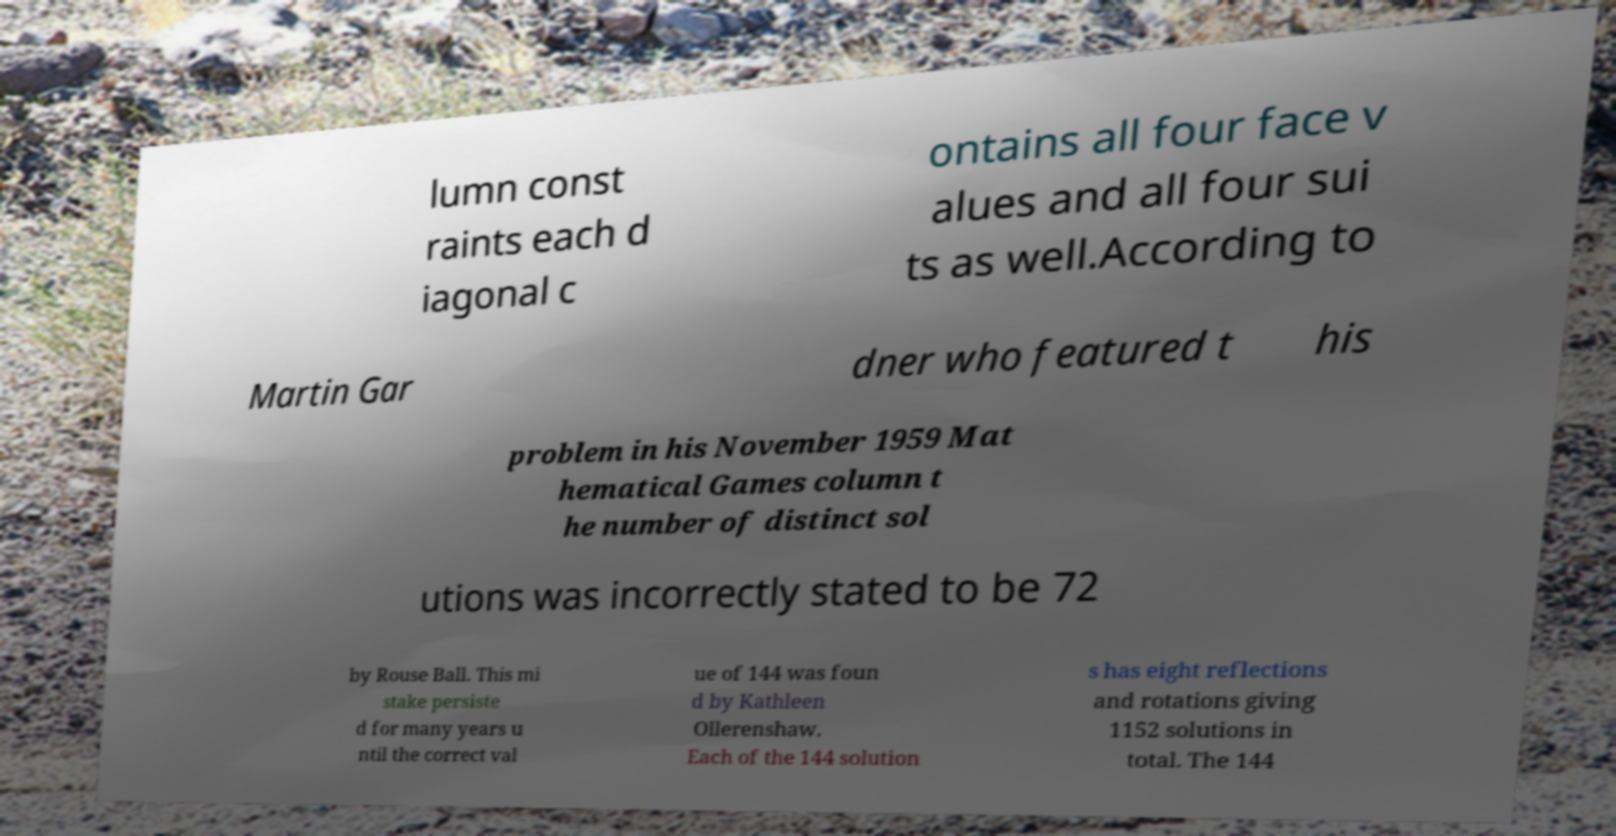Please read and relay the text visible in this image. What does it say? lumn const raints each d iagonal c ontains all four face v alues and all four sui ts as well.According to Martin Gar dner who featured t his problem in his November 1959 Mat hematical Games column t he number of distinct sol utions was incorrectly stated to be 72 by Rouse Ball. This mi stake persiste d for many years u ntil the correct val ue of 144 was foun d by Kathleen Ollerenshaw. Each of the 144 solution s has eight reflections and rotations giving 1152 solutions in total. The 144 